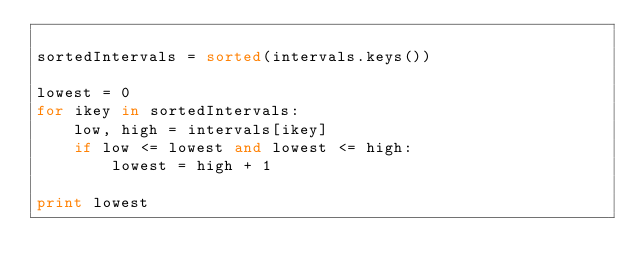Convert code to text. <code><loc_0><loc_0><loc_500><loc_500><_Python_>
sortedIntervals = sorted(intervals.keys())

lowest = 0
for ikey in sortedIntervals:
    low, high = intervals[ikey]
    if low <= lowest and lowest <= high:
        lowest = high + 1

print lowest
</code> 